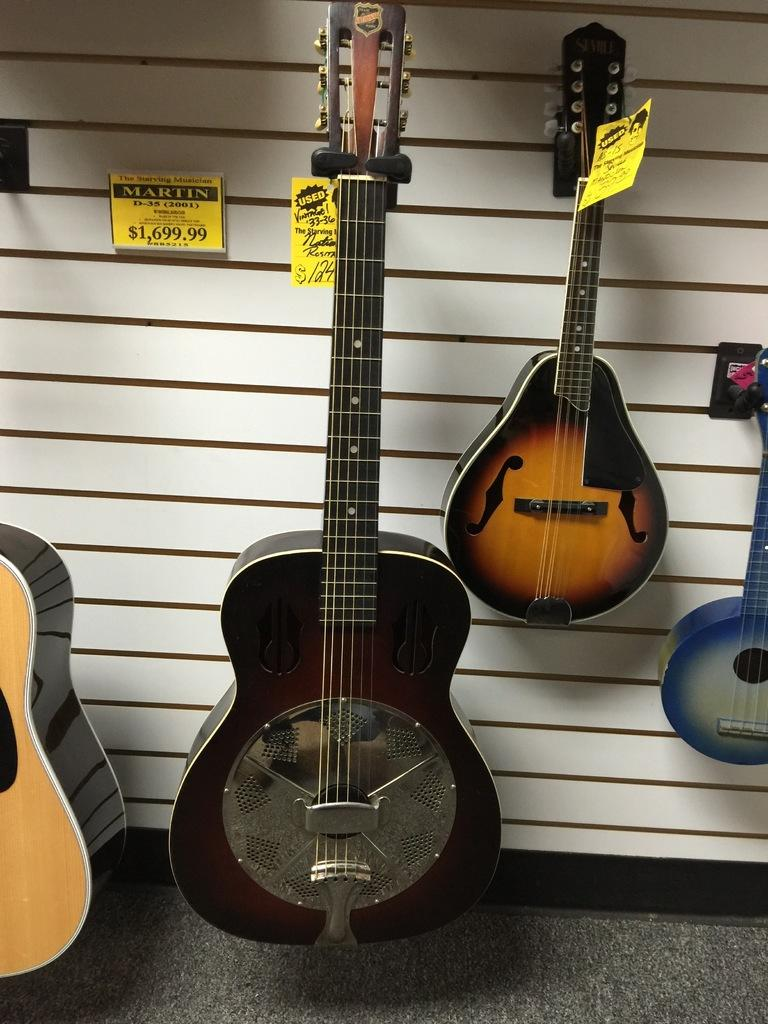How many guitars are in the image? There are four guitars of different sizes in the image. What is behind the guitars? There is a wall behind the guitars. What can be seen on the wall? Some text is written on the wall. How are the guitars marked or identified? The guitars are tagged with a paper. What type of meat is being prepared in the image? There is no meat or any indication of food preparation in the image; it features guitars and a wall with text. 